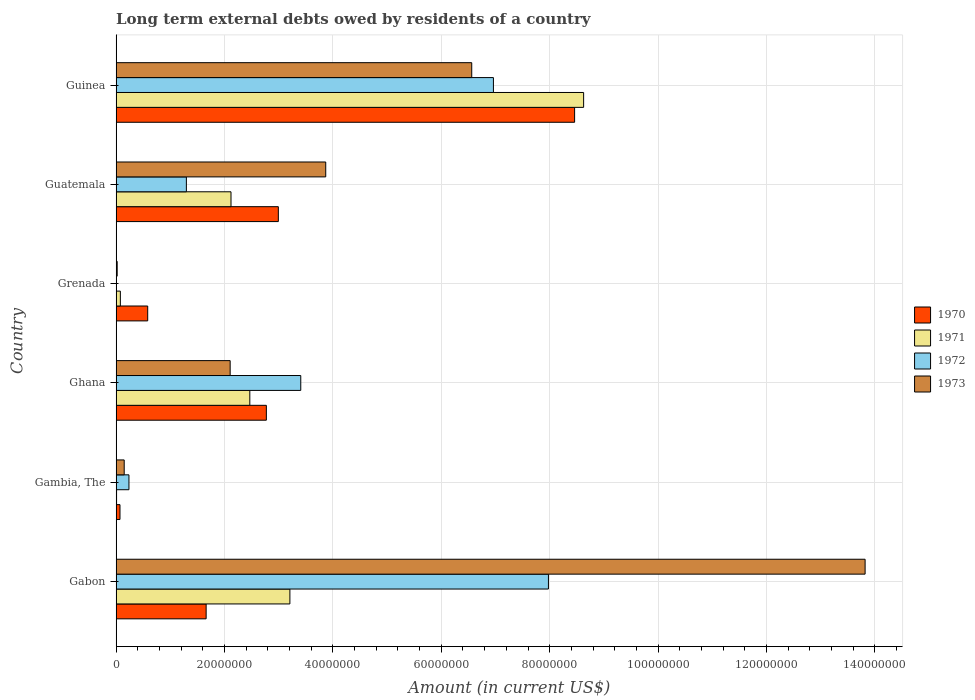How many different coloured bars are there?
Your answer should be compact. 4. Are the number of bars per tick equal to the number of legend labels?
Make the answer very short. No. How many bars are there on the 1st tick from the top?
Provide a succinct answer. 4. How many bars are there on the 5th tick from the bottom?
Provide a succinct answer. 4. What is the label of the 6th group of bars from the top?
Give a very brief answer. Gabon. What is the amount of long-term external debts owed by residents in 1972 in Guinea?
Offer a terse response. 6.96e+07. Across all countries, what is the maximum amount of long-term external debts owed by residents in 1973?
Give a very brief answer. 1.38e+08. In which country was the amount of long-term external debts owed by residents in 1973 maximum?
Offer a very short reply. Gabon. What is the total amount of long-term external debts owed by residents in 1970 in the graph?
Your answer should be compact. 1.65e+08. What is the difference between the amount of long-term external debts owed by residents in 1972 in Ghana and that in Guatemala?
Give a very brief answer. 2.11e+07. What is the difference between the amount of long-term external debts owed by residents in 1973 in Ghana and the amount of long-term external debts owed by residents in 1972 in Grenada?
Your answer should be compact. 2.10e+07. What is the average amount of long-term external debts owed by residents in 1973 per country?
Offer a very short reply. 4.42e+07. What is the difference between the amount of long-term external debts owed by residents in 1970 and amount of long-term external debts owed by residents in 1973 in Guinea?
Provide a succinct answer. 1.90e+07. What is the ratio of the amount of long-term external debts owed by residents in 1972 in Guatemala to that in Guinea?
Ensure brevity in your answer.  0.19. Is the amount of long-term external debts owed by residents in 1973 in Gambia, The less than that in Guinea?
Give a very brief answer. Yes. Is the difference between the amount of long-term external debts owed by residents in 1970 in Gabon and Guinea greater than the difference between the amount of long-term external debts owed by residents in 1973 in Gabon and Guinea?
Ensure brevity in your answer.  No. What is the difference between the highest and the second highest amount of long-term external debts owed by residents in 1971?
Provide a short and direct response. 5.42e+07. What is the difference between the highest and the lowest amount of long-term external debts owed by residents in 1973?
Offer a terse response. 1.38e+08. Is the sum of the amount of long-term external debts owed by residents in 1970 in Gabon and Ghana greater than the maximum amount of long-term external debts owed by residents in 1972 across all countries?
Ensure brevity in your answer.  No. How many bars are there?
Provide a short and direct response. 23. Are all the bars in the graph horizontal?
Your answer should be compact. Yes. What is the difference between two consecutive major ticks on the X-axis?
Provide a short and direct response. 2.00e+07. Where does the legend appear in the graph?
Offer a terse response. Center right. How are the legend labels stacked?
Ensure brevity in your answer.  Vertical. What is the title of the graph?
Offer a terse response. Long term external debts owed by residents of a country. What is the label or title of the X-axis?
Your response must be concise. Amount (in current US$). What is the label or title of the Y-axis?
Offer a terse response. Country. What is the Amount (in current US$) in 1970 in Gabon?
Provide a short and direct response. 1.66e+07. What is the Amount (in current US$) of 1971 in Gabon?
Give a very brief answer. 3.21e+07. What is the Amount (in current US$) of 1972 in Gabon?
Give a very brief answer. 7.98e+07. What is the Amount (in current US$) of 1973 in Gabon?
Offer a terse response. 1.38e+08. What is the Amount (in current US$) in 1970 in Gambia, The?
Provide a short and direct response. 7.11e+05. What is the Amount (in current US$) of 1971 in Gambia, The?
Your answer should be compact. 8.00e+04. What is the Amount (in current US$) in 1972 in Gambia, The?
Ensure brevity in your answer.  2.37e+06. What is the Amount (in current US$) in 1973 in Gambia, The?
Offer a very short reply. 1.49e+06. What is the Amount (in current US$) of 1970 in Ghana?
Your answer should be compact. 2.77e+07. What is the Amount (in current US$) of 1971 in Ghana?
Ensure brevity in your answer.  2.47e+07. What is the Amount (in current US$) in 1972 in Ghana?
Your response must be concise. 3.41e+07. What is the Amount (in current US$) of 1973 in Ghana?
Keep it short and to the point. 2.10e+07. What is the Amount (in current US$) in 1970 in Grenada?
Offer a terse response. 5.82e+06. What is the Amount (in current US$) of 1971 in Grenada?
Give a very brief answer. 7.80e+05. What is the Amount (in current US$) in 1973 in Grenada?
Give a very brief answer. 1.95e+05. What is the Amount (in current US$) in 1970 in Guatemala?
Provide a short and direct response. 2.99e+07. What is the Amount (in current US$) in 1971 in Guatemala?
Give a very brief answer. 2.12e+07. What is the Amount (in current US$) in 1972 in Guatemala?
Ensure brevity in your answer.  1.30e+07. What is the Amount (in current US$) of 1973 in Guatemala?
Make the answer very short. 3.87e+07. What is the Amount (in current US$) in 1970 in Guinea?
Ensure brevity in your answer.  8.46e+07. What is the Amount (in current US$) of 1971 in Guinea?
Offer a terse response. 8.63e+07. What is the Amount (in current US$) of 1972 in Guinea?
Ensure brevity in your answer.  6.96e+07. What is the Amount (in current US$) of 1973 in Guinea?
Provide a succinct answer. 6.56e+07. Across all countries, what is the maximum Amount (in current US$) in 1970?
Give a very brief answer. 8.46e+07. Across all countries, what is the maximum Amount (in current US$) of 1971?
Offer a very short reply. 8.63e+07. Across all countries, what is the maximum Amount (in current US$) of 1972?
Your answer should be compact. 7.98e+07. Across all countries, what is the maximum Amount (in current US$) of 1973?
Your answer should be compact. 1.38e+08. Across all countries, what is the minimum Amount (in current US$) of 1970?
Offer a very short reply. 7.11e+05. Across all countries, what is the minimum Amount (in current US$) in 1973?
Give a very brief answer. 1.95e+05. What is the total Amount (in current US$) of 1970 in the graph?
Offer a terse response. 1.65e+08. What is the total Amount (in current US$) of 1971 in the graph?
Offer a very short reply. 1.65e+08. What is the total Amount (in current US$) in 1972 in the graph?
Provide a short and direct response. 1.99e+08. What is the total Amount (in current US$) in 1973 in the graph?
Give a very brief answer. 2.65e+08. What is the difference between the Amount (in current US$) in 1970 in Gabon and that in Gambia, The?
Keep it short and to the point. 1.59e+07. What is the difference between the Amount (in current US$) of 1971 in Gabon and that in Gambia, The?
Provide a short and direct response. 3.20e+07. What is the difference between the Amount (in current US$) in 1972 in Gabon and that in Gambia, The?
Your answer should be very brief. 7.74e+07. What is the difference between the Amount (in current US$) of 1973 in Gabon and that in Gambia, The?
Provide a succinct answer. 1.37e+08. What is the difference between the Amount (in current US$) in 1970 in Gabon and that in Ghana?
Your response must be concise. -1.11e+07. What is the difference between the Amount (in current US$) in 1971 in Gabon and that in Ghana?
Your response must be concise. 7.40e+06. What is the difference between the Amount (in current US$) in 1972 in Gabon and that in Ghana?
Provide a short and direct response. 4.57e+07. What is the difference between the Amount (in current US$) of 1973 in Gabon and that in Ghana?
Offer a very short reply. 1.17e+08. What is the difference between the Amount (in current US$) in 1970 in Gabon and that in Grenada?
Your answer should be compact. 1.08e+07. What is the difference between the Amount (in current US$) in 1971 in Gabon and that in Grenada?
Offer a terse response. 3.13e+07. What is the difference between the Amount (in current US$) of 1973 in Gabon and that in Grenada?
Your answer should be very brief. 1.38e+08. What is the difference between the Amount (in current US$) of 1970 in Gabon and that in Guatemala?
Your answer should be compact. -1.33e+07. What is the difference between the Amount (in current US$) in 1971 in Gabon and that in Guatemala?
Your answer should be compact. 1.09e+07. What is the difference between the Amount (in current US$) of 1972 in Gabon and that in Guatemala?
Provide a succinct answer. 6.68e+07. What is the difference between the Amount (in current US$) in 1973 in Gabon and that in Guatemala?
Provide a succinct answer. 9.95e+07. What is the difference between the Amount (in current US$) in 1970 in Gabon and that in Guinea?
Make the answer very short. -6.80e+07. What is the difference between the Amount (in current US$) of 1971 in Gabon and that in Guinea?
Your answer should be very brief. -5.42e+07. What is the difference between the Amount (in current US$) in 1972 in Gabon and that in Guinea?
Make the answer very short. 1.02e+07. What is the difference between the Amount (in current US$) in 1973 in Gabon and that in Guinea?
Make the answer very short. 7.26e+07. What is the difference between the Amount (in current US$) in 1970 in Gambia, The and that in Ghana?
Offer a very short reply. -2.70e+07. What is the difference between the Amount (in current US$) in 1971 in Gambia, The and that in Ghana?
Give a very brief answer. -2.46e+07. What is the difference between the Amount (in current US$) of 1972 in Gambia, The and that in Ghana?
Your answer should be compact. -3.17e+07. What is the difference between the Amount (in current US$) in 1973 in Gambia, The and that in Ghana?
Offer a very short reply. -1.96e+07. What is the difference between the Amount (in current US$) in 1970 in Gambia, The and that in Grenada?
Provide a succinct answer. -5.11e+06. What is the difference between the Amount (in current US$) of 1971 in Gambia, The and that in Grenada?
Your answer should be very brief. -7.00e+05. What is the difference between the Amount (in current US$) in 1973 in Gambia, The and that in Grenada?
Offer a terse response. 1.30e+06. What is the difference between the Amount (in current US$) of 1970 in Gambia, The and that in Guatemala?
Provide a short and direct response. -2.92e+07. What is the difference between the Amount (in current US$) in 1971 in Gambia, The and that in Guatemala?
Offer a terse response. -2.11e+07. What is the difference between the Amount (in current US$) in 1972 in Gambia, The and that in Guatemala?
Provide a succinct answer. -1.06e+07. What is the difference between the Amount (in current US$) of 1973 in Gambia, The and that in Guatemala?
Give a very brief answer. -3.72e+07. What is the difference between the Amount (in current US$) in 1970 in Gambia, The and that in Guinea?
Offer a terse response. -8.39e+07. What is the difference between the Amount (in current US$) in 1971 in Gambia, The and that in Guinea?
Provide a succinct answer. -8.62e+07. What is the difference between the Amount (in current US$) of 1972 in Gambia, The and that in Guinea?
Ensure brevity in your answer.  -6.72e+07. What is the difference between the Amount (in current US$) in 1973 in Gambia, The and that in Guinea?
Provide a succinct answer. -6.41e+07. What is the difference between the Amount (in current US$) of 1970 in Ghana and that in Grenada?
Ensure brevity in your answer.  2.19e+07. What is the difference between the Amount (in current US$) of 1971 in Ghana and that in Grenada?
Offer a very short reply. 2.39e+07. What is the difference between the Amount (in current US$) in 1973 in Ghana and that in Grenada?
Provide a succinct answer. 2.08e+07. What is the difference between the Amount (in current US$) in 1970 in Ghana and that in Guatemala?
Ensure brevity in your answer.  -2.21e+06. What is the difference between the Amount (in current US$) in 1971 in Ghana and that in Guatemala?
Offer a very short reply. 3.47e+06. What is the difference between the Amount (in current US$) of 1972 in Ghana and that in Guatemala?
Give a very brief answer. 2.11e+07. What is the difference between the Amount (in current US$) of 1973 in Ghana and that in Guatemala?
Give a very brief answer. -1.76e+07. What is the difference between the Amount (in current US$) in 1970 in Ghana and that in Guinea?
Your answer should be compact. -5.69e+07. What is the difference between the Amount (in current US$) of 1971 in Ghana and that in Guinea?
Keep it short and to the point. -6.16e+07. What is the difference between the Amount (in current US$) in 1972 in Ghana and that in Guinea?
Give a very brief answer. -3.55e+07. What is the difference between the Amount (in current US$) of 1973 in Ghana and that in Guinea?
Offer a terse response. -4.46e+07. What is the difference between the Amount (in current US$) of 1970 in Grenada and that in Guatemala?
Provide a short and direct response. -2.41e+07. What is the difference between the Amount (in current US$) of 1971 in Grenada and that in Guatemala?
Offer a terse response. -2.04e+07. What is the difference between the Amount (in current US$) in 1973 in Grenada and that in Guatemala?
Offer a terse response. -3.85e+07. What is the difference between the Amount (in current US$) in 1970 in Grenada and that in Guinea?
Provide a short and direct response. -7.88e+07. What is the difference between the Amount (in current US$) in 1971 in Grenada and that in Guinea?
Your answer should be very brief. -8.55e+07. What is the difference between the Amount (in current US$) of 1973 in Grenada and that in Guinea?
Your answer should be very brief. -6.54e+07. What is the difference between the Amount (in current US$) in 1970 in Guatemala and that in Guinea?
Make the answer very short. -5.47e+07. What is the difference between the Amount (in current US$) in 1971 in Guatemala and that in Guinea?
Make the answer very short. -6.51e+07. What is the difference between the Amount (in current US$) of 1972 in Guatemala and that in Guinea?
Your answer should be very brief. -5.67e+07. What is the difference between the Amount (in current US$) of 1973 in Guatemala and that in Guinea?
Provide a short and direct response. -2.69e+07. What is the difference between the Amount (in current US$) in 1970 in Gabon and the Amount (in current US$) in 1971 in Gambia, The?
Keep it short and to the point. 1.65e+07. What is the difference between the Amount (in current US$) in 1970 in Gabon and the Amount (in current US$) in 1972 in Gambia, The?
Keep it short and to the point. 1.42e+07. What is the difference between the Amount (in current US$) in 1970 in Gabon and the Amount (in current US$) in 1973 in Gambia, The?
Give a very brief answer. 1.51e+07. What is the difference between the Amount (in current US$) in 1971 in Gabon and the Amount (in current US$) in 1972 in Gambia, The?
Keep it short and to the point. 2.97e+07. What is the difference between the Amount (in current US$) of 1971 in Gabon and the Amount (in current US$) of 1973 in Gambia, The?
Provide a short and direct response. 3.06e+07. What is the difference between the Amount (in current US$) in 1972 in Gabon and the Amount (in current US$) in 1973 in Gambia, The?
Provide a short and direct response. 7.83e+07. What is the difference between the Amount (in current US$) of 1970 in Gabon and the Amount (in current US$) of 1971 in Ghana?
Offer a terse response. -8.06e+06. What is the difference between the Amount (in current US$) in 1970 in Gabon and the Amount (in current US$) in 1972 in Ghana?
Your response must be concise. -1.75e+07. What is the difference between the Amount (in current US$) of 1970 in Gabon and the Amount (in current US$) of 1973 in Ghana?
Give a very brief answer. -4.43e+06. What is the difference between the Amount (in current US$) in 1971 in Gabon and the Amount (in current US$) in 1972 in Ghana?
Provide a succinct answer. -2.00e+06. What is the difference between the Amount (in current US$) of 1971 in Gabon and the Amount (in current US$) of 1973 in Ghana?
Keep it short and to the point. 1.10e+07. What is the difference between the Amount (in current US$) in 1972 in Gabon and the Amount (in current US$) in 1973 in Ghana?
Your response must be concise. 5.87e+07. What is the difference between the Amount (in current US$) in 1970 in Gabon and the Amount (in current US$) in 1971 in Grenada?
Keep it short and to the point. 1.58e+07. What is the difference between the Amount (in current US$) of 1970 in Gabon and the Amount (in current US$) of 1973 in Grenada?
Provide a short and direct response. 1.64e+07. What is the difference between the Amount (in current US$) of 1971 in Gabon and the Amount (in current US$) of 1973 in Grenada?
Keep it short and to the point. 3.19e+07. What is the difference between the Amount (in current US$) in 1972 in Gabon and the Amount (in current US$) in 1973 in Grenada?
Provide a succinct answer. 7.96e+07. What is the difference between the Amount (in current US$) in 1970 in Gabon and the Amount (in current US$) in 1971 in Guatemala?
Keep it short and to the point. -4.59e+06. What is the difference between the Amount (in current US$) in 1970 in Gabon and the Amount (in current US$) in 1972 in Guatemala?
Offer a terse response. 3.65e+06. What is the difference between the Amount (in current US$) of 1970 in Gabon and the Amount (in current US$) of 1973 in Guatemala?
Provide a succinct answer. -2.21e+07. What is the difference between the Amount (in current US$) of 1971 in Gabon and the Amount (in current US$) of 1972 in Guatemala?
Ensure brevity in your answer.  1.91e+07. What is the difference between the Amount (in current US$) in 1971 in Gabon and the Amount (in current US$) in 1973 in Guatemala?
Offer a very short reply. -6.61e+06. What is the difference between the Amount (in current US$) of 1972 in Gabon and the Amount (in current US$) of 1973 in Guatemala?
Provide a short and direct response. 4.11e+07. What is the difference between the Amount (in current US$) of 1970 in Gabon and the Amount (in current US$) of 1971 in Guinea?
Make the answer very short. -6.97e+07. What is the difference between the Amount (in current US$) in 1970 in Gabon and the Amount (in current US$) in 1972 in Guinea?
Ensure brevity in your answer.  -5.30e+07. What is the difference between the Amount (in current US$) in 1970 in Gabon and the Amount (in current US$) in 1973 in Guinea?
Your response must be concise. -4.90e+07. What is the difference between the Amount (in current US$) of 1971 in Gabon and the Amount (in current US$) of 1972 in Guinea?
Give a very brief answer. -3.76e+07. What is the difference between the Amount (in current US$) of 1971 in Gabon and the Amount (in current US$) of 1973 in Guinea?
Make the answer very short. -3.36e+07. What is the difference between the Amount (in current US$) in 1972 in Gabon and the Amount (in current US$) in 1973 in Guinea?
Keep it short and to the point. 1.42e+07. What is the difference between the Amount (in current US$) of 1970 in Gambia, The and the Amount (in current US$) of 1971 in Ghana?
Offer a terse response. -2.40e+07. What is the difference between the Amount (in current US$) in 1970 in Gambia, The and the Amount (in current US$) in 1972 in Ghana?
Your answer should be compact. -3.34e+07. What is the difference between the Amount (in current US$) of 1970 in Gambia, The and the Amount (in current US$) of 1973 in Ghana?
Provide a short and direct response. -2.03e+07. What is the difference between the Amount (in current US$) of 1971 in Gambia, The and the Amount (in current US$) of 1972 in Ghana?
Your response must be concise. -3.40e+07. What is the difference between the Amount (in current US$) in 1971 in Gambia, The and the Amount (in current US$) in 1973 in Ghana?
Provide a short and direct response. -2.10e+07. What is the difference between the Amount (in current US$) of 1972 in Gambia, The and the Amount (in current US$) of 1973 in Ghana?
Offer a terse response. -1.87e+07. What is the difference between the Amount (in current US$) in 1970 in Gambia, The and the Amount (in current US$) in 1971 in Grenada?
Make the answer very short. -6.90e+04. What is the difference between the Amount (in current US$) of 1970 in Gambia, The and the Amount (in current US$) of 1973 in Grenada?
Provide a short and direct response. 5.16e+05. What is the difference between the Amount (in current US$) in 1971 in Gambia, The and the Amount (in current US$) in 1973 in Grenada?
Offer a terse response. -1.15e+05. What is the difference between the Amount (in current US$) of 1972 in Gambia, The and the Amount (in current US$) of 1973 in Grenada?
Ensure brevity in your answer.  2.17e+06. What is the difference between the Amount (in current US$) in 1970 in Gambia, The and the Amount (in current US$) in 1971 in Guatemala?
Give a very brief answer. -2.05e+07. What is the difference between the Amount (in current US$) of 1970 in Gambia, The and the Amount (in current US$) of 1972 in Guatemala?
Provide a succinct answer. -1.23e+07. What is the difference between the Amount (in current US$) in 1970 in Gambia, The and the Amount (in current US$) in 1973 in Guatemala?
Offer a terse response. -3.80e+07. What is the difference between the Amount (in current US$) of 1971 in Gambia, The and the Amount (in current US$) of 1972 in Guatemala?
Offer a terse response. -1.29e+07. What is the difference between the Amount (in current US$) in 1971 in Gambia, The and the Amount (in current US$) in 1973 in Guatemala?
Give a very brief answer. -3.86e+07. What is the difference between the Amount (in current US$) in 1972 in Gambia, The and the Amount (in current US$) in 1973 in Guatemala?
Offer a terse response. -3.63e+07. What is the difference between the Amount (in current US$) of 1970 in Gambia, The and the Amount (in current US$) of 1971 in Guinea?
Provide a succinct answer. -8.55e+07. What is the difference between the Amount (in current US$) in 1970 in Gambia, The and the Amount (in current US$) in 1972 in Guinea?
Your answer should be compact. -6.89e+07. What is the difference between the Amount (in current US$) of 1970 in Gambia, The and the Amount (in current US$) of 1973 in Guinea?
Your answer should be compact. -6.49e+07. What is the difference between the Amount (in current US$) in 1971 in Gambia, The and the Amount (in current US$) in 1972 in Guinea?
Your answer should be very brief. -6.95e+07. What is the difference between the Amount (in current US$) of 1971 in Gambia, The and the Amount (in current US$) of 1973 in Guinea?
Your answer should be compact. -6.55e+07. What is the difference between the Amount (in current US$) in 1972 in Gambia, The and the Amount (in current US$) in 1973 in Guinea?
Keep it short and to the point. -6.32e+07. What is the difference between the Amount (in current US$) in 1970 in Ghana and the Amount (in current US$) in 1971 in Grenada?
Your response must be concise. 2.69e+07. What is the difference between the Amount (in current US$) of 1970 in Ghana and the Amount (in current US$) of 1973 in Grenada?
Make the answer very short. 2.75e+07. What is the difference between the Amount (in current US$) of 1971 in Ghana and the Amount (in current US$) of 1973 in Grenada?
Make the answer very short. 2.45e+07. What is the difference between the Amount (in current US$) of 1972 in Ghana and the Amount (in current US$) of 1973 in Grenada?
Your answer should be very brief. 3.39e+07. What is the difference between the Amount (in current US$) in 1970 in Ghana and the Amount (in current US$) in 1971 in Guatemala?
Offer a very short reply. 6.52e+06. What is the difference between the Amount (in current US$) in 1970 in Ghana and the Amount (in current US$) in 1972 in Guatemala?
Provide a succinct answer. 1.48e+07. What is the difference between the Amount (in current US$) of 1970 in Ghana and the Amount (in current US$) of 1973 in Guatemala?
Provide a succinct answer. -1.10e+07. What is the difference between the Amount (in current US$) of 1971 in Ghana and the Amount (in current US$) of 1972 in Guatemala?
Provide a succinct answer. 1.17e+07. What is the difference between the Amount (in current US$) in 1971 in Ghana and the Amount (in current US$) in 1973 in Guatemala?
Offer a terse response. -1.40e+07. What is the difference between the Amount (in current US$) in 1972 in Ghana and the Amount (in current US$) in 1973 in Guatemala?
Provide a succinct answer. -4.61e+06. What is the difference between the Amount (in current US$) in 1970 in Ghana and the Amount (in current US$) in 1971 in Guinea?
Give a very brief answer. -5.85e+07. What is the difference between the Amount (in current US$) of 1970 in Ghana and the Amount (in current US$) of 1972 in Guinea?
Offer a terse response. -4.19e+07. What is the difference between the Amount (in current US$) of 1970 in Ghana and the Amount (in current US$) of 1973 in Guinea?
Your answer should be very brief. -3.79e+07. What is the difference between the Amount (in current US$) of 1971 in Ghana and the Amount (in current US$) of 1972 in Guinea?
Provide a succinct answer. -4.49e+07. What is the difference between the Amount (in current US$) of 1971 in Ghana and the Amount (in current US$) of 1973 in Guinea?
Give a very brief answer. -4.09e+07. What is the difference between the Amount (in current US$) of 1972 in Ghana and the Amount (in current US$) of 1973 in Guinea?
Offer a very short reply. -3.15e+07. What is the difference between the Amount (in current US$) in 1970 in Grenada and the Amount (in current US$) in 1971 in Guatemala?
Provide a short and direct response. -1.54e+07. What is the difference between the Amount (in current US$) of 1970 in Grenada and the Amount (in current US$) of 1972 in Guatemala?
Make the answer very short. -7.14e+06. What is the difference between the Amount (in current US$) in 1970 in Grenada and the Amount (in current US$) in 1973 in Guatemala?
Your answer should be very brief. -3.28e+07. What is the difference between the Amount (in current US$) of 1971 in Grenada and the Amount (in current US$) of 1972 in Guatemala?
Offer a terse response. -1.22e+07. What is the difference between the Amount (in current US$) of 1971 in Grenada and the Amount (in current US$) of 1973 in Guatemala?
Your response must be concise. -3.79e+07. What is the difference between the Amount (in current US$) in 1970 in Grenada and the Amount (in current US$) in 1971 in Guinea?
Offer a very short reply. -8.04e+07. What is the difference between the Amount (in current US$) in 1970 in Grenada and the Amount (in current US$) in 1972 in Guinea?
Offer a terse response. -6.38e+07. What is the difference between the Amount (in current US$) of 1970 in Grenada and the Amount (in current US$) of 1973 in Guinea?
Keep it short and to the point. -5.98e+07. What is the difference between the Amount (in current US$) in 1971 in Grenada and the Amount (in current US$) in 1972 in Guinea?
Keep it short and to the point. -6.88e+07. What is the difference between the Amount (in current US$) of 1971 in Grenada and the Amount (in current US$) of 1973 in Guinea?
Your answer should be very brief. -6.48e+07. What is the difference between the Amount (in current US$) of 1970 in Guatemala and the Amount (in current US$) of 1971 in Guinea?
Your answer should be compact. -5.63e+07. What is the difference between the Amount (in current US$) of 1970 in Guatemala and the Amount (in current US$) of 1972 in Guinea?
Give a very brief answer. -3.97e+07. What is the difference between the Amount (in current US$) in 1970 in Guatemala and the Amount (in current US$) in 1973 in Guinea?
Provide a short and direct response. -3.57e+07. What is the difference between the Amount (in current US$) of 1971 in Guatemala and the Amount (in current US$) of 1972 in Guinea?
Make the answer very short. -4.84e+07. What is the difference between the Amount (in current US$) in 1971 in Guatemala and the Amount (in current US$) in 1973 in Guinea?
Keep it short and to the point. -4.44e+07. What is the difference between the Amount (in current US$) of 1972 in Guatemala and the Amount (in current US$) of 1973 in Guinea?
Your response must be concise. -5.27e+07. What is the average Amount (in current US$) of 1970 per country?
Give a very brief answer. 2.76e+07. What is the average Amount (in current US$) in 1971 per country?
Your response must be concise. 2.75e+07. What is the average Amount (in current US$) of 1972 per country?
Give a very brief answer. 3.31e+07. What is the average Amount (in current US$) in 1973 per country?
Keep it short and to the point. 4.42e+07. What is the difference between the Amount (in current US$) of 1970 and Amount (in current US$) of 1971 in Gabon?
Provide a short and direct response. -1.55e+07. What is the difference between the Amount (in current US$) of 1970 and Amount (in current US$) of 1972 in Gabon?
Keep it short and to the point. -6.32e+07. What is the difference between the Amount (in current US$) in 1970 and Amount (in current US$) in 1973 in Gabon?
Your response must be concise. -1.22e+08. What is the difference between the Amount (in current US$) in 1971 and Amount (in current US$) in 1972 in Gabon?
Keep it short and to the point. -4.77e+07. What is the difference between the Amount (in current US$) in 1971 and Amount (in current US$) in 1973 in Gabon?
Give a very brief answer. -1.06e+08. What is the difference between the Amount (in current US$) of 1972 and Amount (in current US$) of 1973 in Gabon?
Your answer should be compact. -5.84e+07. What is the difference between the Amount (in current US$) of 1970 and Amount (in current US$) of 1971 in Gambia, The?
Provide a short and direct response. 6.31e+05. What is the difference between the Amount (in current US$) in 1970 and Amount (in current US$) in 1972 in Gambia, The?
Offer a terse response. -1.66e+06. What is the difference between the Amount (in current US$) in 1970 and Amount (in current US$) in 1973 in Gambia, The?
Provide a short and direct response. -7.79e+05. What is the difference between the Amount (in current US$) of 1971 and Amount (in current US$) of 1972 in Gambia, The?
Give a very brief answer. -2.29e+06. What is the difference between the Amount (in current US$) of 1971 and Amount (in current US$) of 1973 in Gambia, The?
Offer a terse response. -1.41e+06. What is the difference between the Amount (in current US$) of 1972 and Amount (in current US$) of 1973 in Gambia, The?
Provide a succinct answer. 8.77e+05. What is the difference between the Amount (in current US$) in 1970 and Amount (in current US$) in 1971 in Ghana?
Provide a succinct answer. 3.05e+06. What is the difference between the Amount (in current US$) in 1970 and Amount (in current US$) in 1972 in Ghana?
Provide a short and direct response. -6.35e+06. What is the difference between the Amount (in current US$) of 1970 and Amount (in current US$) of 1973 in Ghana?
Provide a short and direct response. 6.68e+06. What is the difference between the Amount (in current US$) in 1971 and Amount (in current US$) in 1972 in Ghana?
Your answer should be very brief. -9.40e+06. What is the difference between the Amount (in current US$) of 1971 and Amount (in current US$) of 1973 in Ghana?
Ensure brevity in your answer.  3.63e+06. What is the difference between the Amount (in current US$) of 1972 and Amount (in current US$) of 1973 in Ghana?
Provide a short and direct response. 1.30e+07. What is the difference between the Amount (in current US$) in 1970 and Amount (in current US$) in 1971 in Grenada?
Provide a short and direct response. 5.04e+06. What is the difference between the Amount (in current US$) of 1970 and Amount (in current US$) of 1973 in Grenada?
Offer a terse response. 5.63e+06. What is the difference between the Amount (in current US$) of 1971 and Amount (in current US$) of 1973 in Grenada?
Give a very brief answer. 5.85e+05. What is the difference between the Amount (in current US$) in 1970 and Amount (in current US$) in 1971 in Guatemala?
Your response must be concise. 8.73e+06. What is the difference between the Amount (in current US$) in 1970 and Amount (in current US$) in 1972 in Guatemala?
Make the answer very short. 1.70e+07. What is the difference between the Amount (in current US$) in 1970 and Amount (in current US$) in 1973 in Guatemala?
Keep it short and to the point. -8.74e+06. What is the difference between the Amount (in current US$) of 1971 and Amount (in current US$) of 1972 in Guatemala?
Your response must be concise. 8.23e+06. What is the difference between the Amount (in current US$) in 1971 and Amount (in current US$) in 1973 in Guatemala?
Make the answer very short. -1.75e+07. What is the difference between the Amount (in current US$) in 1972 and Amount (in current US$) in 1973 in Guatemala?
Your answer should be compact. -2.57e+07. What is the difference between the Amount (in current US$) of 1970 and Amount (in current US$) of 1971 in Guinea?
Your response must be concise. -1.66e+06. What is the difference between the Amount (in current US$) of 1970 and Amount (in current US$) of 1972 in Guinea?
Offer a terse response. 1.50e+07. What is the difference between the Amount (in current US$) in 1970 and Amount (in current US$) in 1973 in Guinea?
Offer a terse response. 1.90e+07. What is the difference between the Amount (in current US$) of 1971 and Amount (in current US$) of 1972 in Guinea?
Ensure brevity in your answer.  1.66e+07. What is the difference between the Amount (in current US$) in 1971 and Amount (in current US$) in 1973 in Guinea?
Provide a short and direct response. 2.06e+07. What is the difference between the Amount (in current US$) of 1972 and Amount (in current US$) of 1973 in Guinea?
Offer a terse response. 4.00e+06. What is the ratio of the Amount (in current US$) of 1970 in Gabon to that in Gambia, The?
Make the answer very short. 23.36. What is the ratio of the Amount (in current US$) in 1971 in Gabon to that in Gambia, The?
Provide a succinct answer. 400.79. What is the ratio of the Amount (in current US$) of 1972 in Gabon to that in Gambia, The?
Ensure brevity in your answer.  33.7. What is the ratio of the Amount (in current US$) in 1973 in Gabon to that in Gambia, The?
Provide a succinct answer. 92.75. What is the ratio of the Amount (in current US$) in 1970 in Gabon to that in Ghana?
Provide a succinct answer. 0.6. What is the ratio of the Amount (in current US$) in 1971 in Gabon to that in Ghana?
Offer a terse response. 1.3. What is the ratio of the Amount (in current US$) in 1972 in Gabon to that in Ghana?
Your response must be concise. 2.34. What is the ratio of the Amount (in current US$) in 1973 in Gabon to that in Ghana?
Your response must be concise. 6.57. What is the ratio of the Amount (in current US$) of 1970 in Gabon to that in Grenada?
Give a very brief answer. 2.85. What is the ratio of the Amount (in current US$) in 1971 in Gabon to that in Grenada?
Offer a terse response. 41.11. What is the ratio of the Amount (in current US$) in 1973 in Gabon to that in Grenada?
Offer a terse response. 708.71. What is the ratio of the Amount (in current US$) of 1970 in Gabon to that in Guatemala?
Offer a terse response. 0.55. What is the ratio of the Amount (in current US$) in 1971 in Gabon to that in Guatemala?
Your answer should be compact. 1.51. What is the ratio of the Amount (in current US$) in 1972 in Gabon to that in Guatemala?
Your answer should be compact. 6.15. What is the ratio of the Amount (in current US$) of 1973 in Gabon to that in Guatemala?
Make the answer very short. 3.57. What is the ratio of the Amount (in current US$) of 1970 in Gabon to that in Guinea?
Ensure brevity in your answer.  0.2. What is the ratio of the Amount (in current US$) in 1971 in Gabon to that in Guinea?
Ensure brevity in your answer.  0.37. What is the ratio of the Amount (in current US$) in 1972 in Gabon to that in Guinea?
Your response must be concise. 1.15. What is the ratio of the Amount (in current US$) of 1973 in Gabon to that in Guinea?
Offer a terse response. 2.11. What is the ratio of the Amount (in current US$) in 1970 in Gambia, The to that in Ghana?
Provide a succinct answer. 0.03. What is the ratio of the Amount (in current US$) of 1971 in Gambia, The to that in Ghana?
Your response must be concise. 0. What is the ratio of the Amount (in current US$) of 1972 in Gambia, The to that in Ghana?
Your response must be concise. 0.07. What is the ratio of the Amount (in current US$) in 1973 in Gambia, The to that in Ghana?
Keep it short and to the point. 0.07. What is the ratio of the Amount (in current US$) in 1970 in Gambia, The to that in Grenada?
Keep it short and to the point. 0.12. What is the ratio of the Amount (in current US$) of 1971 in Gambia, The to that in Grenada?
Your response must be concise. 0.1. What is the ratio of the Amount (in current US$) in 1973 in Gambia, The to that in Grenada?
Ensure brevity in your answer.  7.64. What is the ratio of the Amount (in current US$) in 1970 in Gambia, The to that in Guatemala?
Offer a terse response. 0.02. What is the ratio of the Amount (in current US$) in 1971 in Gambia, The to that in Guatemala?
Provide a succinct answer. 0. What is the ratio of the Amount (in current US$) in 1972 in Gambia, The to that in Guatemala?
Give a very brief answer. 0.18. What is the ratio of the Amount (in current US$) of 1973 in Gambia, The to that in Guatemala?
Offer a terse response. 0.04. What is the ratio of the Amount (in current US$) of 1970 in Gambia, The to that in Guinea?
Offer a terse response. 0.01. What is the ratio of the Amount (in current US$) of 1971 in Gambia, The to that in Guinea?
Make the answer very short. 0. What is the ratio of the Amount (in current US$) of 1972 in Gambia, The to that in Guinea?
Offer a very short reply. 0.03. What is the ratio of the Amount (in current US$) in 1973 in Gambia, The to that in Guinea?
Provide a succinct answer. 0.02. What is the ratio of the Amount (in current US$) in 1970 in Ghana to that in Grenada?
Your answer should be compact. 4.76. What is the ratio of the Amount (in current US$) of 1971 in Ghana to that in Grenada?
Your answer should be compact. 31.63. What is the ratio of the Amount (in current US$) of 1973 in Ghana to that in Grenada?
Ensure brevity in your answer.  107.9. What is the ratio of the Amount (in current US$) of 1970 in Ghana to that in Guatemala?
Your answer should be compact. 0.93. What is the ratio of the Amount (in current US$) of 1971 in Ghana to that in Guatemala?
Ensure brevity in your answer.  1.16. What is the ratio of the Amount (in current US$) in 1972 in Ghana to that in Guatemala?
Make the answer very short. 2.63. What is the ratio of the Amount (in current US$) in 1973 in Ghana to that in Guatemala?
Your response must be concise. 0.54. What is the ratio of the Amount (in current US$) in 1970 in Ghana to that in Guinea?
Your response must be concise. 0.33. What is the ratio of the Amount (in current US$) of 1971 in Ghana to that in Guinea?
Your answer should be compact. 0.29. What is the ratio of the Amount (in current US$) in 1972 in Ghana to that in Guinea?
Provide a short and direct response. 0.49. What is the ratio of the Amount (in current US$) in 1973 in Ghana to that in Guinea?
Make the answer very short. 0.32. What is the ratio of the Amount (in current US$) in 1970 in Grenada to that in Guatemala?
Give a very brief answer. 0.19. What is the ratio of the Amount (in current US$) of 1971 in Grenada to that in Guatemala?
Offer a very short reply. 0.04. What is the ratio of the Amount (in current US$) in 1973 in Grenada to that in Guatemala?
Offer a terse response. 0.01. What is the ratio of the Amount (in current US$) in 1970 in Grenada to that in Guinea?
Your answer should be compact. 0.07. What is the ratio of the Amount (in current US$) in 1971 in Grenada to that in Guinea?
Give a very brief answer. 0.01. What is the ratio of the Amount (in current US$) of 1973 in Grenada to that in Guinea?
Give a very brief answer. 0. What is the ratio of the Amount (in current US$) in 1970 in Guatemala to that in Guinea?
Offer a terse response. 0.35. What is the ratio of the Amount (in current US$) of 1971 in Guatemala to that in Guinea?
Make the answer very short. 0.25. What is the ratio of the Amount (in current US$) in 1972 in Guatemala to that in Guinea?
Offer a very short reply. 0.19. What is the ratio of the Amount (in current US$) in 1973 in Guatemala to that in Guinea?
Ensure brevity in your answer.  0.59. What is the difference between the highest and the second highest Amount (in current US$) in 1970?
Make the answer very short. 5.47e+07. What is the difference between the highest and the second highest Amount (in current US$) of 1971?
Offer a very short reply. 5.42e+07. What is the difference between the highest and the second highest Amount (in current US$) in 1972?
Offer a very short reply. 1.02e+07. What is the difference between the highest and the second highest Amount (in current US$) in 1973?
Your answer should be very brief. 7.26e+07. What is the difference between the highest and the lowest Amount (in current US$) in 1970?
Make the answer very short. 8.39e+07. What is the difference between the highest and the lowest Amount (in current US$) in 1971?
Your answer should be very brief. 8.62e+07. What is the difference between the highest and the lowest Amount (in current US$) of 1972?
Offer a very short reply. 7.98e+07. What is the difference between the highest and the lowest Amount (in current US$) of 1973?
Your answer should be compact. 1.38e+08. 